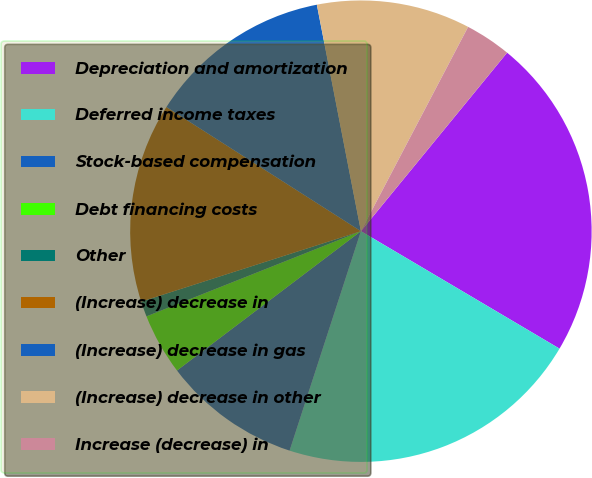Convert chart. <chart><loc_0><loc_0><loc_500><loc_500><pie_chart><fcel>Depreciation and amortization<fcel>Deferred income taxes<fcel>Stock-based compensation<fcel>Debt financing costs<fcel>Other<fcel>(Increase) decrease in<fcel>(Increase) decrease in gas<fcel>(Increase) decrease in other<fcel>Increase (decrease) in<nl><fcel>22.58%<fcel>21.5%<fcel>9.68%<fcel>4.3%<fcel>1.08%<fcel>13.98%<fcel>12.9%<fcel>10.75%<fcel>3.23%<nl></chart> 